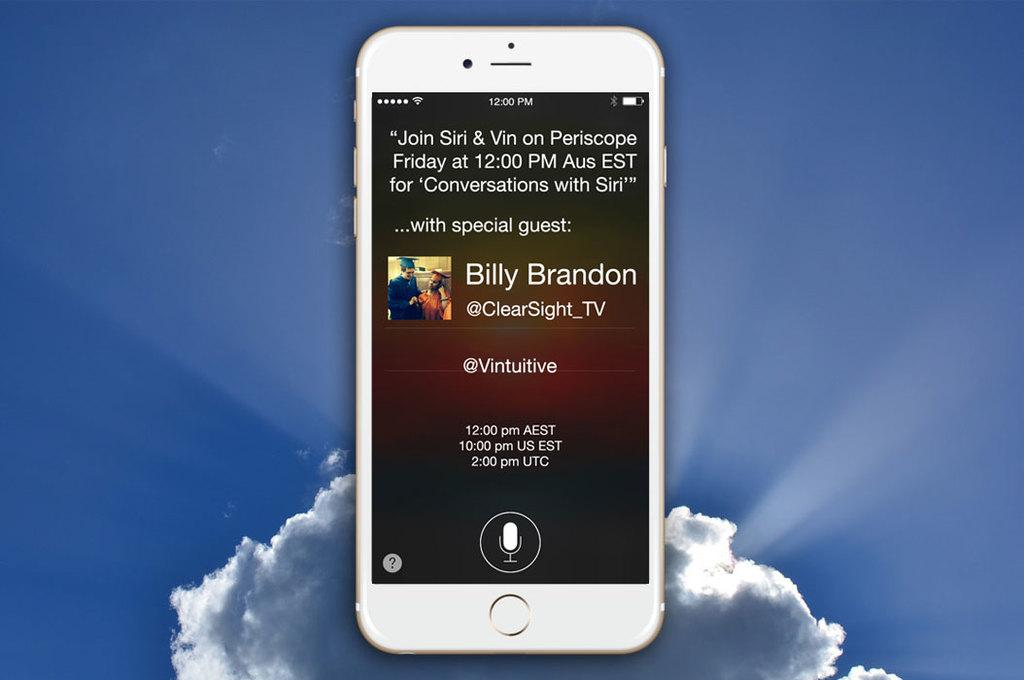<image>
Describe the image concisely. A white iPhone showing a message about a special guest named Billy Brandon. 